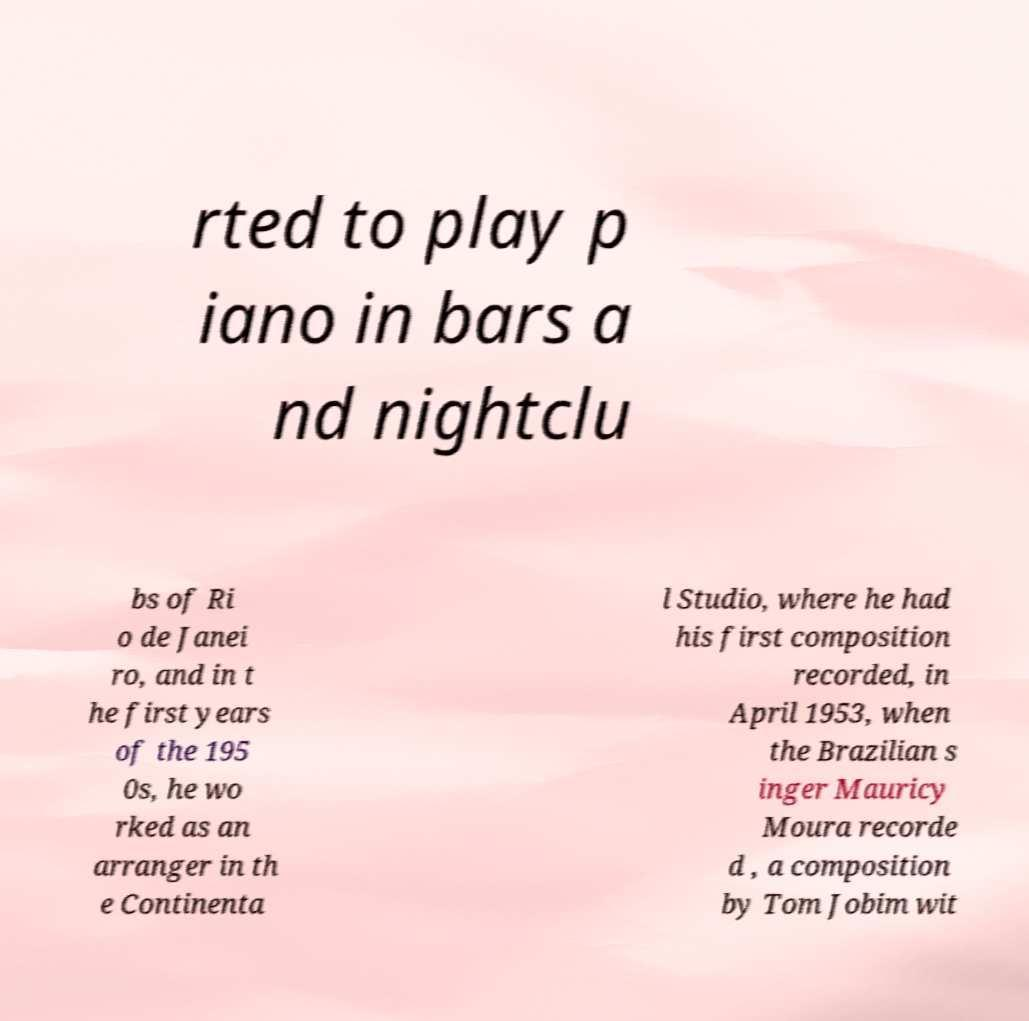There's text embedded in this image that I need extracted. Can you transcribe it verbatim? rted to play p iano in bars a nd nightclu bs of Ri o de Janei ro, and in t he first years of the 195 0s, he wo rked as an arranger in th e Continenta l Studio, where he had his first composition recorded, in April 1953, when the Brazilian s inger Mauricy Moura recorde d , a composition by Tom Jobim wit 